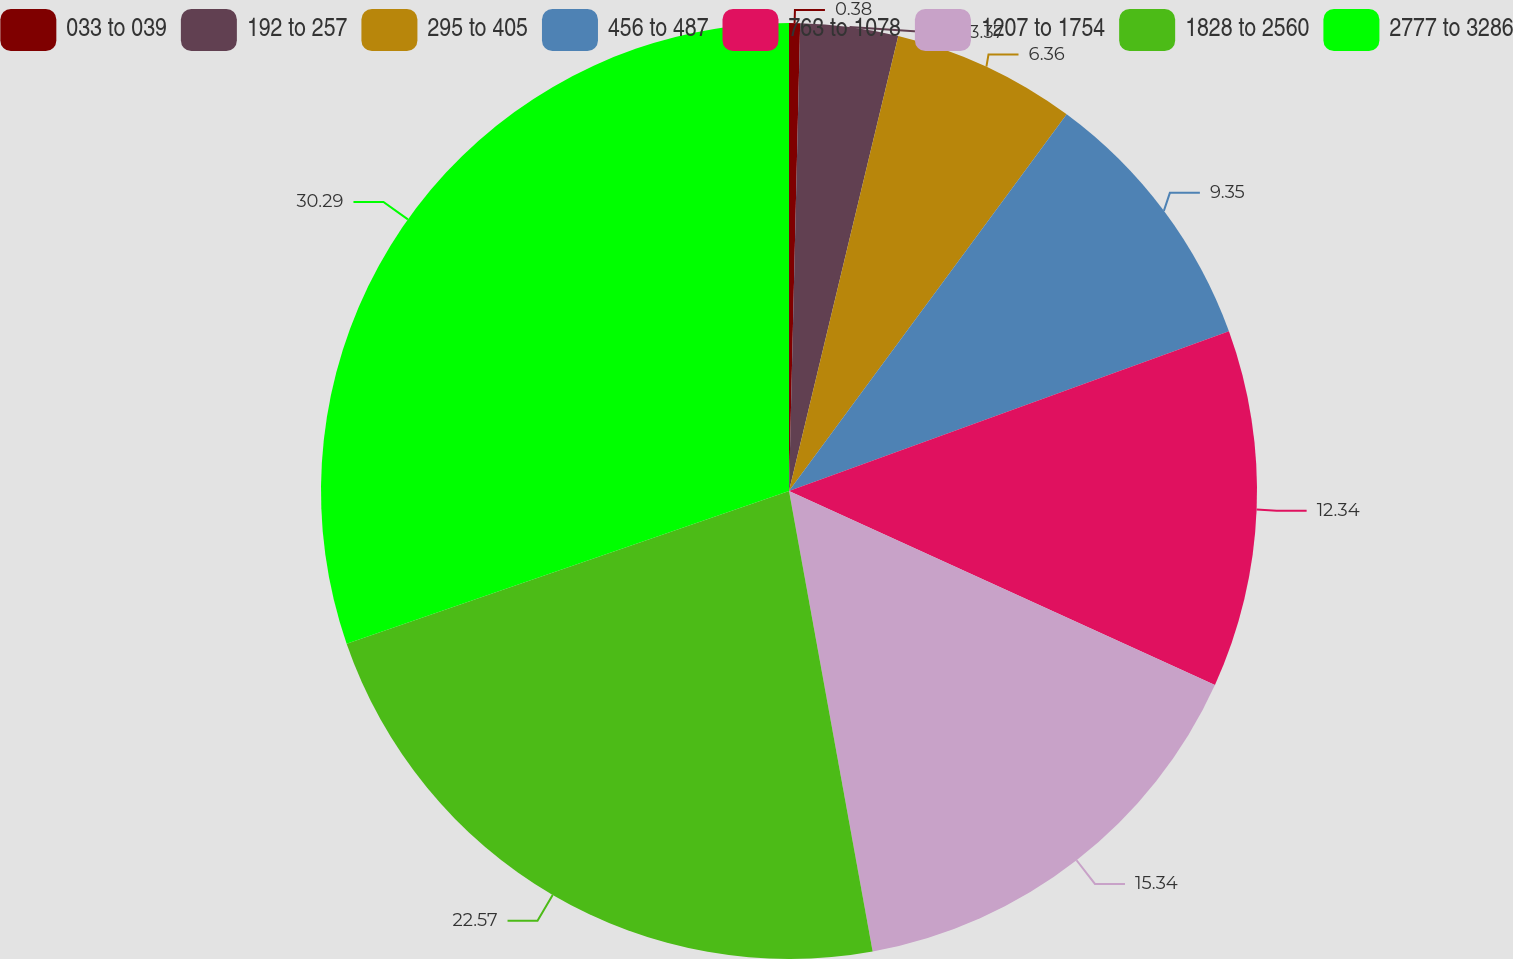Convert chart. <chart><loc_0><loc_0><loc_500><loc_500><pie_chart><fcel>033 to 039<fcel>192 to 257<fcel>295 to 405<fcel>456 to 487<fcel>763 to 1078<fcel>1207 to 1754<fcel>1828 to 2560<fcel>2777 to 3286<nl><fcel>0.38%<fcel>3.37%<fcel>6.36%<fcel>9.35%<fcel>12.34%<fcel>15.34%<fcel>22.57%<fcel>30.29%<nl></chart> 